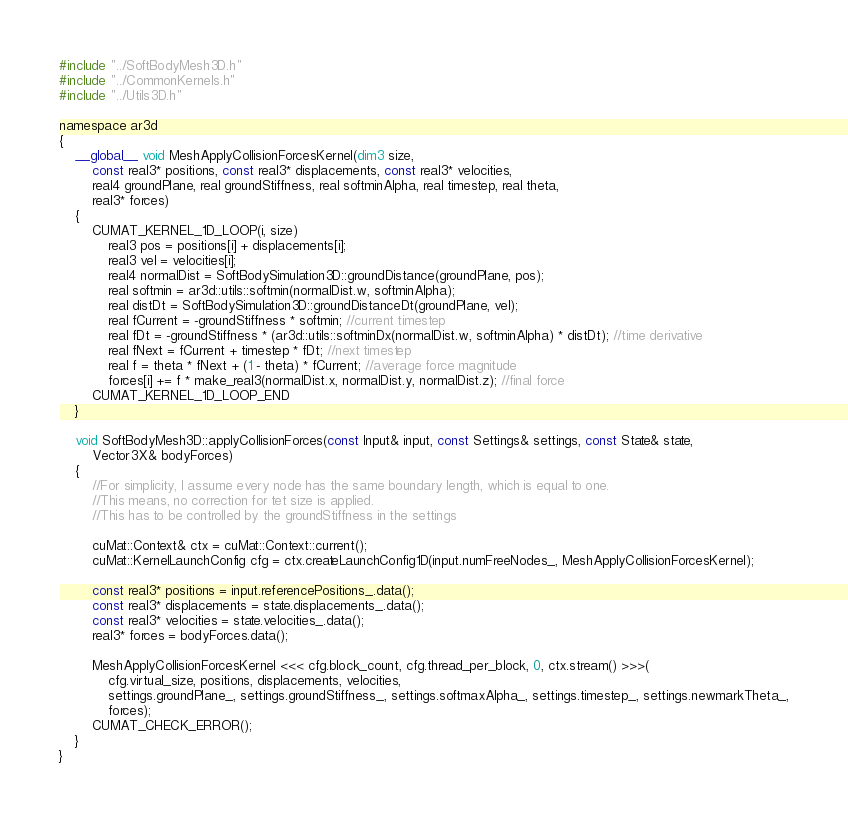Convert code to text. <code><loc_0><loc_0><loc_500><loc_500><_Cuda_>#include "../SoftBodyMesh3D.h"
#include "../CommonKernels.h"
#include "../Utils3D.h"

namespace ar3d
{
	__global__ void MeshApplyCollisionForcesKernel(dim3 size,
		const real3* positions, const real3* displacements, const real3* velocities,
		real4 groundPlane, real groundStiffness, real softminAlpha, real timestep, real theta,
		real3* forces)
	{
		CUMAT_KERNEL_1D_LOOP(i, size)
			real3 pos = positions[i] + displacements[i];
			real3 vel = velocities[i];
			real4 normalDist = SoftBodySimulation3D::groundDistance(groundPlane, pos);
			real softmin = ar3d::utils::softmin(normalDist.w, softminAlpha);
			real distDt = SoftBodySimulation3D::groundDistanceDt(groundPlane, vel);
			real fCurrent = -groundStiffness * softmin; //current timestep
			real fDt = -groundStiffness * (ar3d::utils::softminDx(normalDist.w, softminAlpha) * distDt); //time derivative
			real fNext = fCurrent + timestep * fDt; //next timestep
			real f = theta * fNext + (1 - theta) * fCurrent; //average force magnitude
			forces[i] += f * make_real3(normalDist.x, normalDist.y, normalDist.z); //final force
		CUMAT_KERNEL_1D_LOOP_END
	}

	void SoftBodyMesh3D::applyCollisionForces(const Input& input, const Settings& settings, const State& state,
		Vector3X& bodyForces)
	{
		//For simplicity, I assume every node has the same boundary length, which is equal to one.
		//This means, no correction for tet size is applied.
		//This has to be controlled by the groundStiffness in the settings

		cuMat::Context& ctx = cuMat::Context::current();
		cuMat::KernelLaunchConfig cfg = ctx.createLaunchConfig1D(input.numFreeNodes_, MeshApplyCollisionForcesKernel);
		
		const real3* positions = input.referencePositions_.data();
		const real3* displacements = state.displacements_.data();
		const real3* velocities = state.velocities_.data();
		real3* forces = bodyForces.data();

		MeshApplyCollisionForcesKernel <<< cfg.block_count, cfg.thread_per_block, 0, ctx.stream() >>>(
			cfg.virtual_size, positions, displacements, velocities, 
			settings.groundPlane_, settings.groundStiffness_, settings.softmaxAlpha_, settings.timestep_, settings.newmarkTheta_,
			forces);
		CUMAT_CHECK_ERROR();
	}
}
</code> 